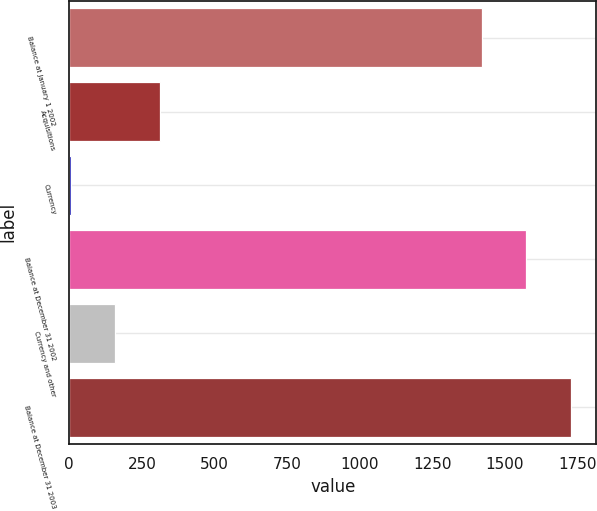Convert chart. <chart><loc_0><loc_0><loc_500><loc_500><bar_chart><fcel>Balance at January 1 2002<fcel>Acquisitions<fcel>Currency<fcel>Balance at December 31 2002<fcel>Currency and other<fcel>Balance at December 31 2003<nl><fcel>1420.8<fcel>311.4<fcel>4.2<fcel>1574.4<fcel>157.8<fcel>1728<nl></chart> 